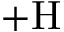<formula> <loc_0><loc_0><loc_500><loc_500>+ H</formula> 